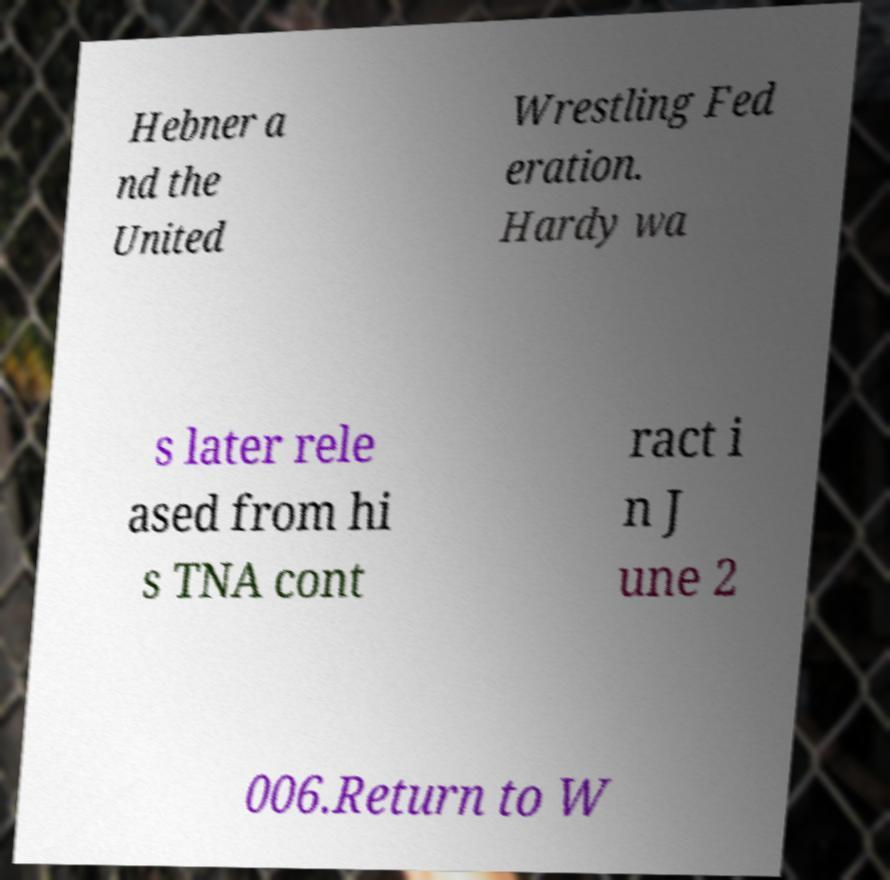Can you read and provide the text displayed in the image?This photo seems to have some interesting text. Can you extract and type it out for me? Hebner a nd the United Wrestling Fed eration. Hardy wa s later rele ased from hi s TNA cont ract i n J une 2 006.Return to W 